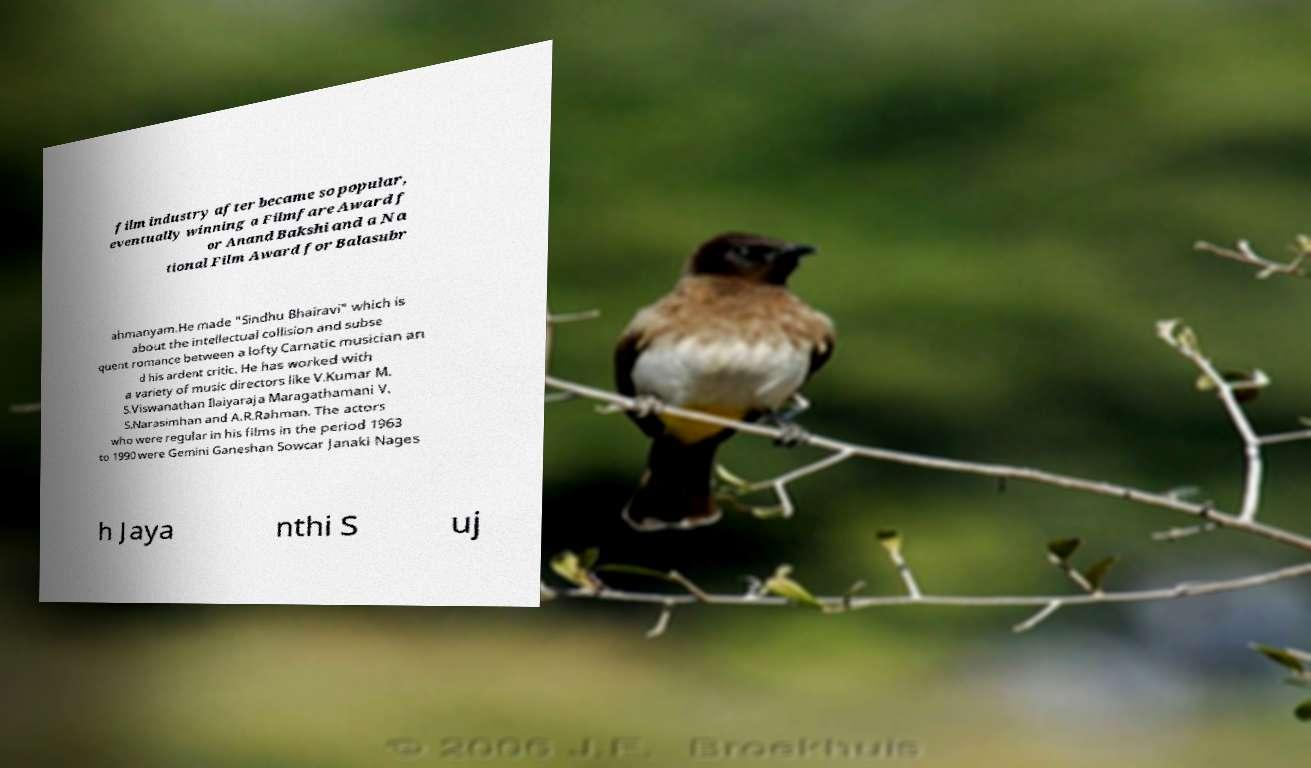For documentation purposes, I need the text within this image transcribed. Could you provide that? film industry after became so popular, eventually winning a Filmfare Award f or Anand Bakshi and a Na tional Film Award for Balasubr ahmanyam.He made "Sindhu Bhairavi" which is about the intellectual collision and subse quent romance between a lofty Carnatic musician an d his ardent critic. He has worked with a variety of music directors like V.Kumar M. S.Viswanathan Ilaiyaraja Maragathamani V. S.Narasimhan and A.R.Rahman. The actors who were regular in his films in the period 1963 to 1990 were Gemini Ganeshan Sowcar Janaki Nages h Jaya nthi S uj 